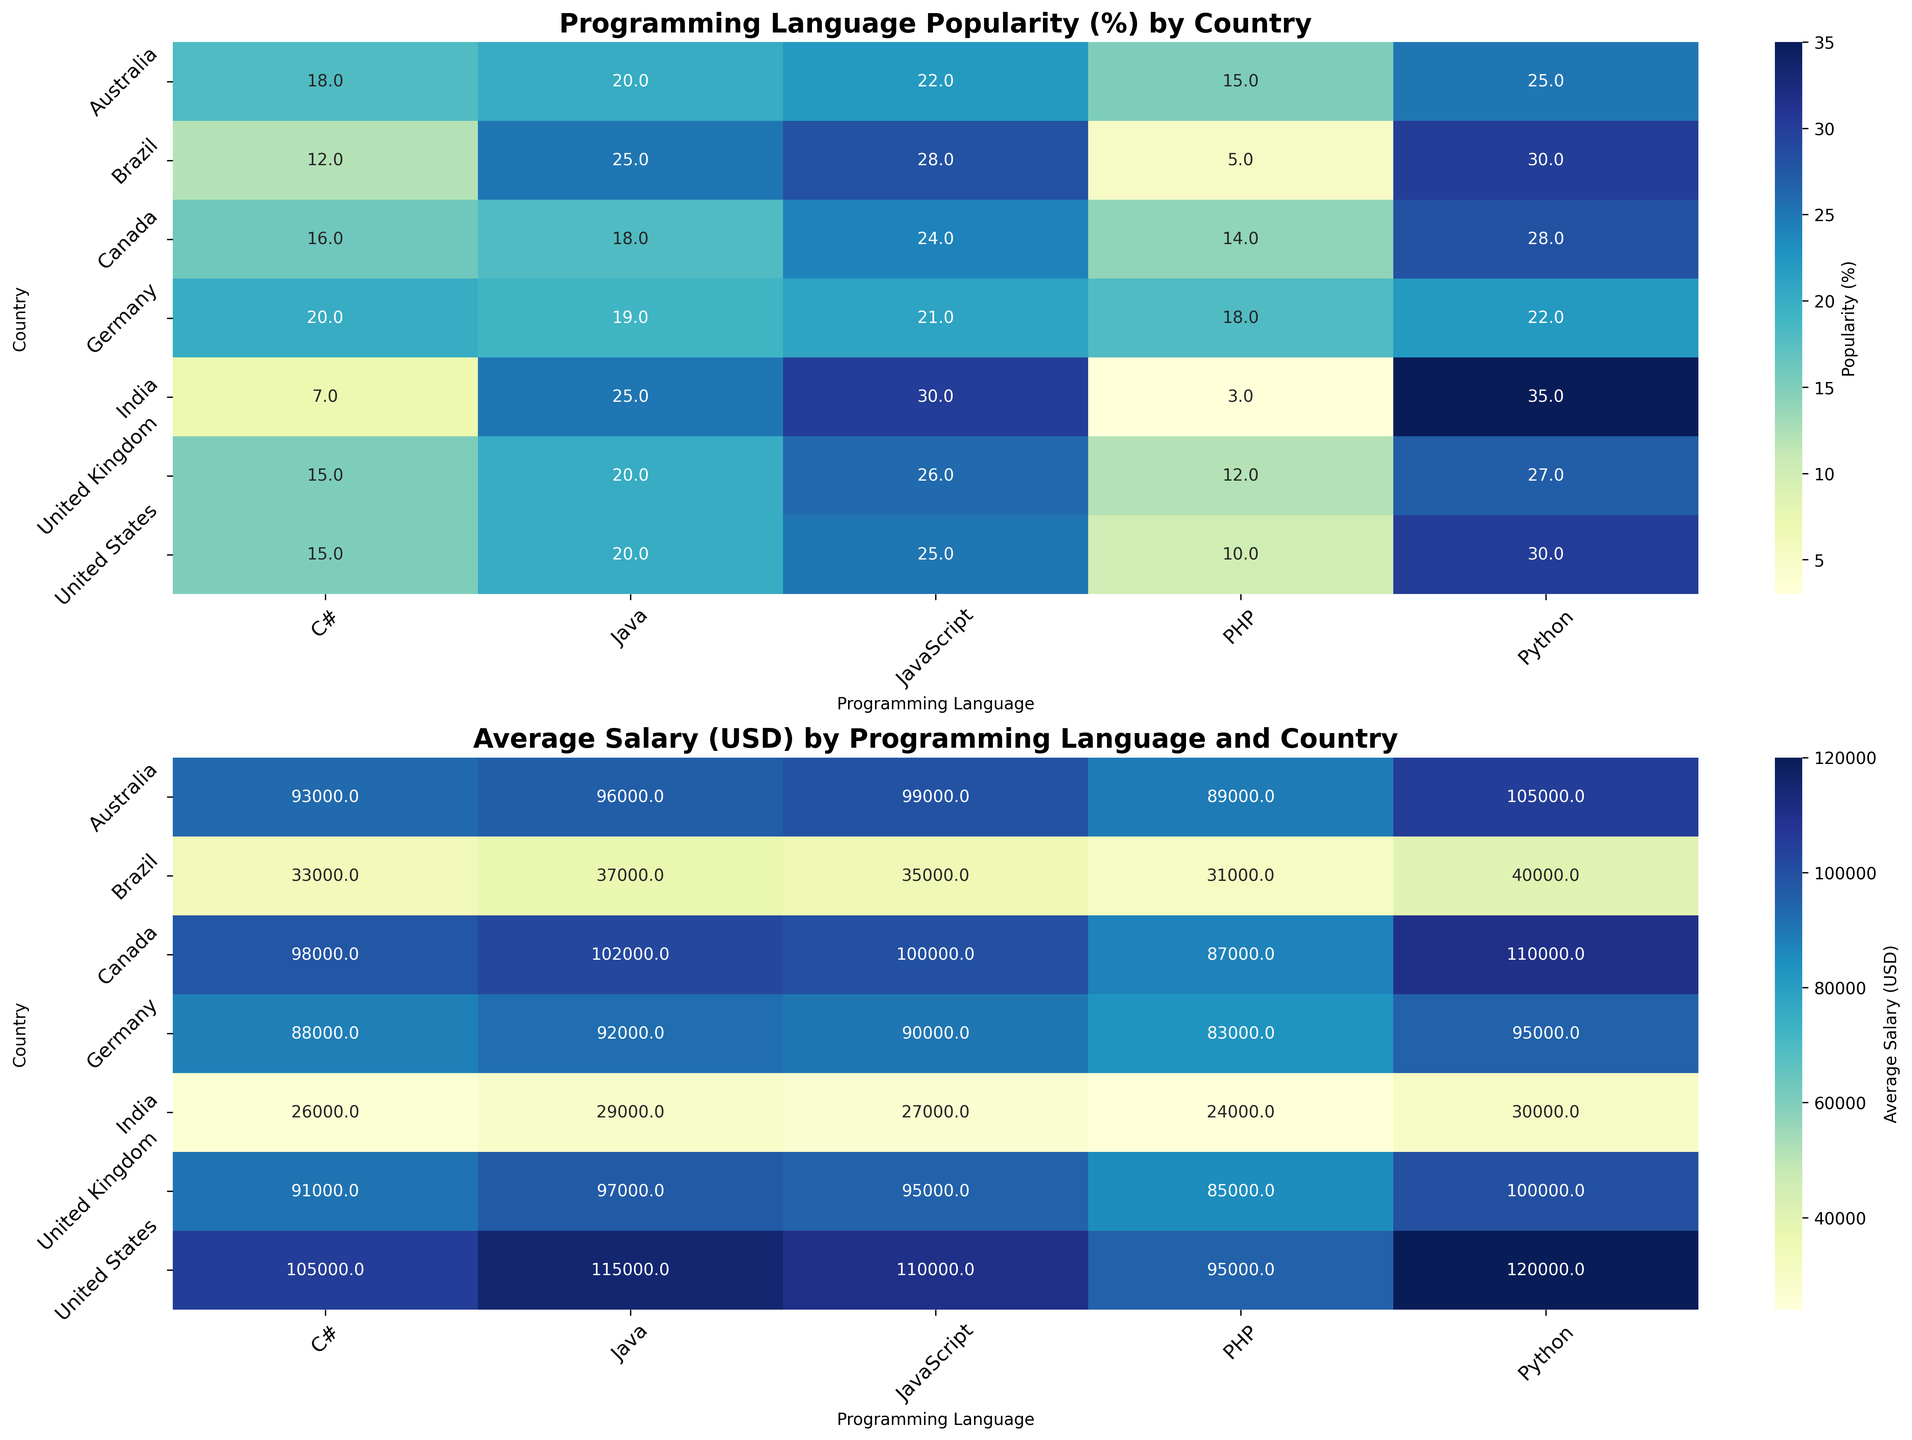Which country has the highest popularity of Python? To determine the country with the highest popularity of Python, look for the darkest shade in the Python column of the popularity heatmap. The country with the highest value is India, with a popularity of 35%.
Answer: India Which country has the lowest average salary for PHP developers? To find the country with the lowest average salary for PHP, look at the PHP column in the salary heatmap and identify the lightest shade. The country with the lowest average salary for PHP developers is India, with an average salary of $24,000.
Answer: India What is the average popularity of JavaScript across all countries? Sum the popularity percentages of JavaScript across all countries (25 + 24 + 21 + 26 + 22 + 30 + 28 = 176) and then divide by the number of countries (7). The average is 176 / 7 ≈ 25.14%.
Answer: 25.14% Which programming language has the highest average salary in the United States? To find the programming language with the highest average salary in the United States, look at the row for the United States in the salary heatmap. The highest value is for Python at $120,000.
Answer: Python Compare the popularity of C# in Germany and India. Which country has a higher popularity and by how much? Look at the C# column for Germany and India in the popularity heatmap. Germany has a popularity of 20%, and India has 7%. The difference is 20 - 7 = 13%.
Answer: Germany by 13% Which country offers the highest average salary for Java developers? To find the highest average salary for Java developers, look at the Java column in the salary heatmap. The highest value is in the United States, with an average salary of $115,000.
Answer: United States What is the sum of the popularities of PHP and C# in Brazil? Sum the popularity percentages of PHP and C# in Brazil (5% + 12% = 17%).
Answer: 17% Which country has a higher average salary for Python developers, Canada or Australia, and what is the difference? Look at the Python column for Canada and Australia in the salary heatmap. Canada has an average salary of $110,000, and Australia has $105,000. The difference is 110,000 - 105,000 = $5,000.
Answer: Canada by $5,000 What is the average salary of all programming languages in the United Kingdom? Sum the average salaries of all programming languages in the United Kingdom (100,000 + 95,000 + 97,000 + 91,000 + 85,000 = 468,000) and divide by the number of programming languages (5). The average salary is 468,000 / 5 = $93,600.
Answer: $93,600 Which programming language is least popular in the United States? To find the least popular programming language in the United States, look at the row for the United States in the popularity heatmap. The lowest percentage is for PHP at 10%.
Answer: PHP 